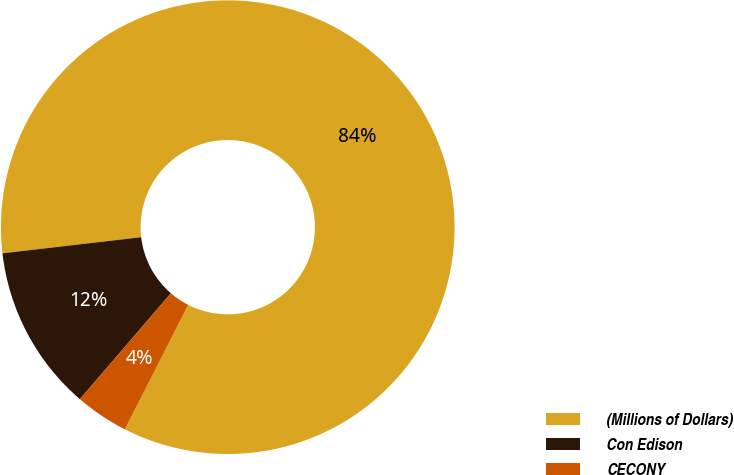Convert chart to OTSL. <chart><loc_0><loc_0><loc_500><loc_500><pie_chart><fcel>(Millions of Dollars)<fcel>Con Edison<fcel>CECONY<nl><fcel>84.33%<fcel>11.86%<fcel>3.81%<nl></chart> 